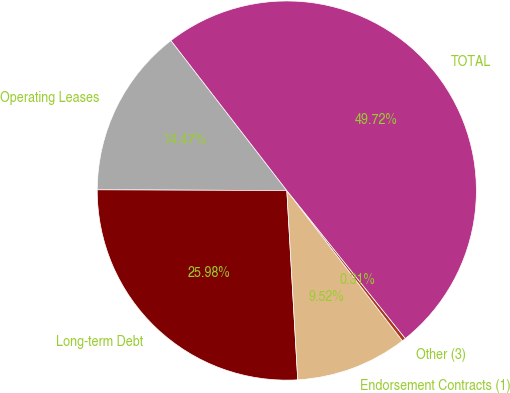Convert chart. <chart><loc_0><loc_0><loc_500><loc_500><pie_chart><fcel>Operating Leases<fcel>Long-term Debt<fcel>Endorsement Contracts (1)<fcel>Other (3)<fcel>TOTAL<nl><fcel>14.47%<fcel>25.98%<fcel>9.52%<fcel>0.31%<fcel>49.72%<nl></chart> 